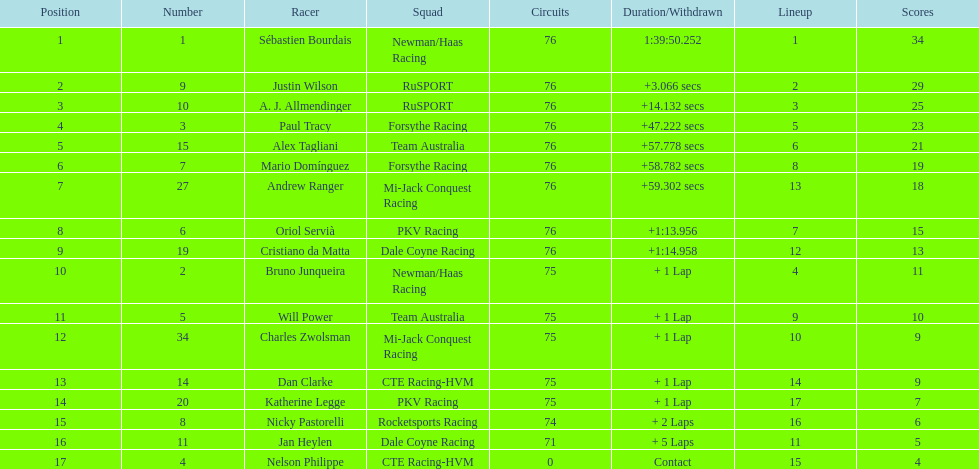What is the total point difference between the driver who received the most points and the driver who received the least? 30. 